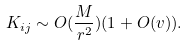<formula> <loc_0><loc_0><loc_500><loc_500>K _ { i j } \sim O ( \frac { M } { r ^ { 2 } } ) ( 1 + O ( v ) ) .</formula> 